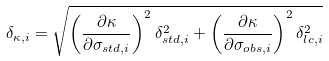<formula> <loc_0><loc_0><loc_500><loc_500>\delta _ { \kappa , i } = \sqrt { \left ( \frac { \partial \kappa } { \partial \sigma _ { s t d , i } } \right ) ^ { 2 } \delta ^ { 2 } _ { s t d , i } + \left ( \frac { \partial \kappa } { \partial \sigma _ { o b s , i } } \right ) ^ { 2 } \delta ^ { 2 } _ { l c , i } }</formula> 